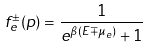Convert formula to latex. <formula><loc_0><loc_0><loc_500><loc_500>f _ { e } ^ { \pm } ( p ) = \frac { 1 } { e ^ { \beta ( E \mp \mu _ { e } ) } + 1 }</formula> 